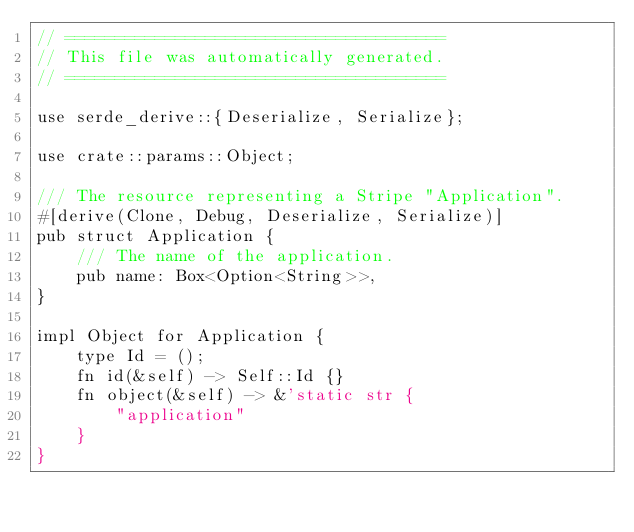<code> <loc_0><loc_0><loc_500><loc_500><_Rust_>// ======================================
// This file was automatically generated.
// ======================================

use serde_derive::{Deserialize, Serialize};

use crate::params::Object;

/// The resource representing a Stripe "Application".
#[derive(Clone, Debug, Deserialize, Serialize)]
pub struct Application {
    /// The name of the application.
    pub name: Box<Option<String>>,
}

impl Object for Application {
    type Id = ();
    fn id(&self) -> Self::Id {}
    fn object(&self) -> &'static str {
        "application"
    }
}
</code> 